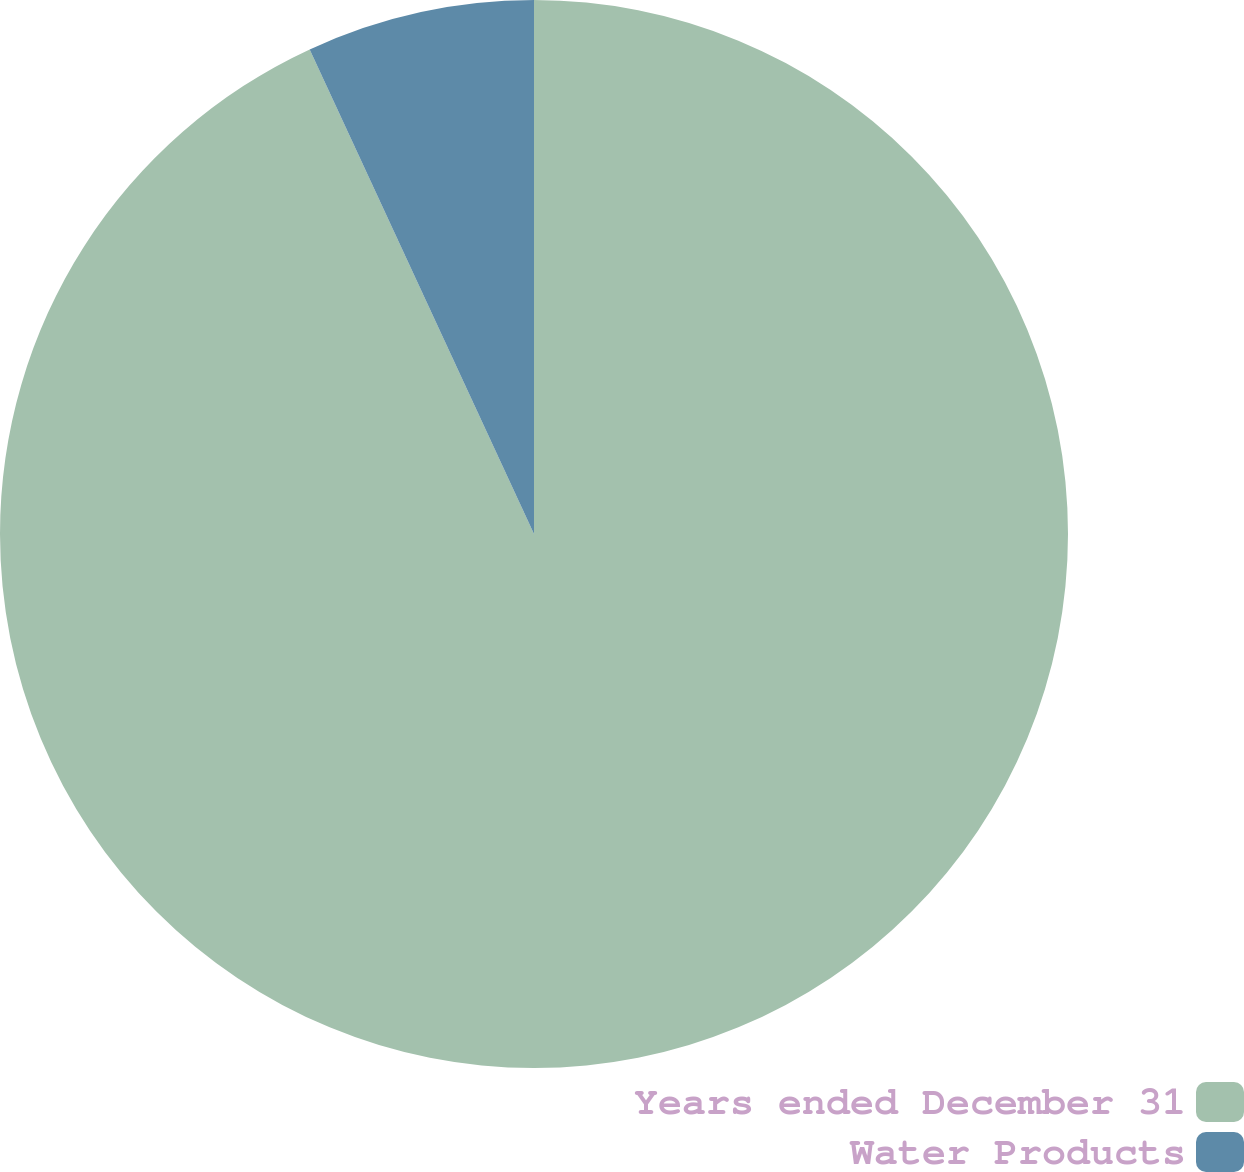Convert chart. <chart><loc_0><loc_0><loc_500><loc_500><pie_chart><fcel>Years ended December 31<fcel>Water Products<nl><fcel>93.1%<fcel>6.9%<nl></chart> 